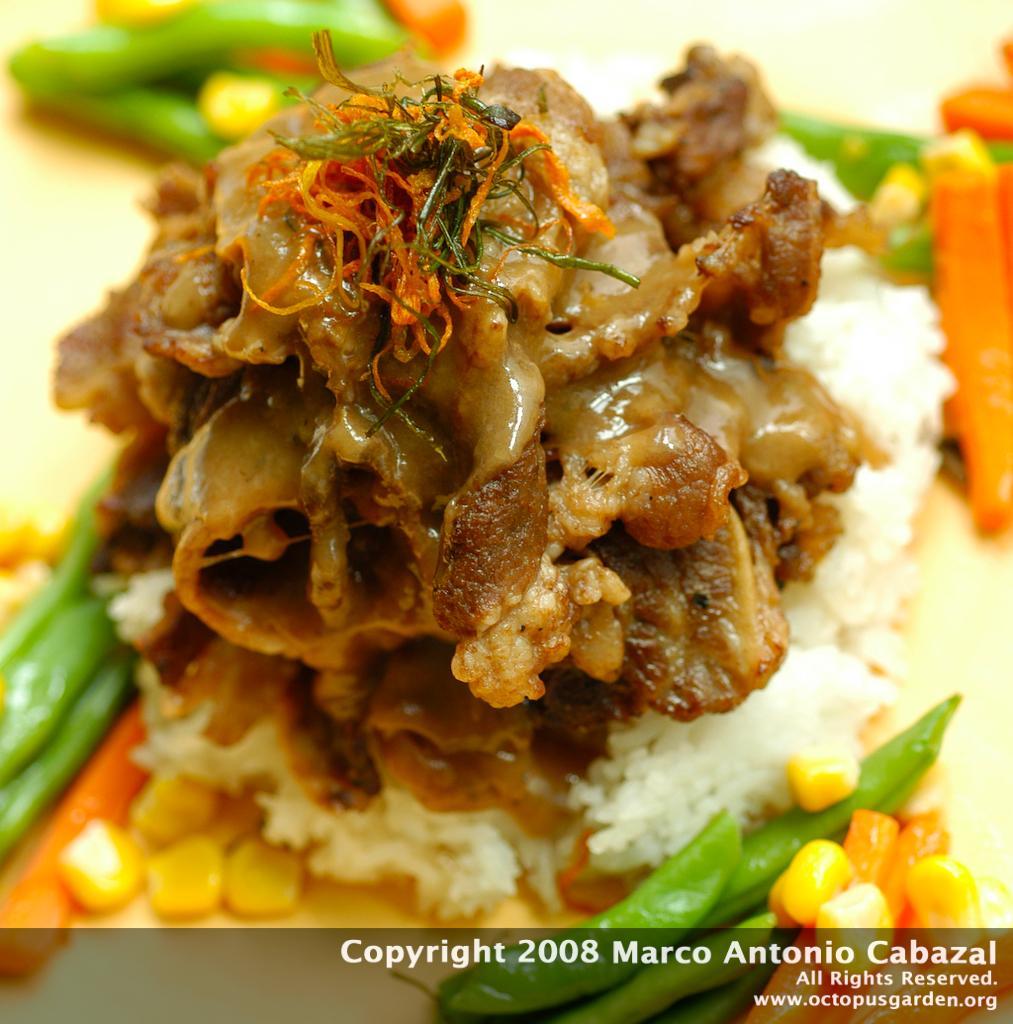How would you summarize this image in a sentence or two? In this picture we can see food items on an object. On the image, there is a watermark. 